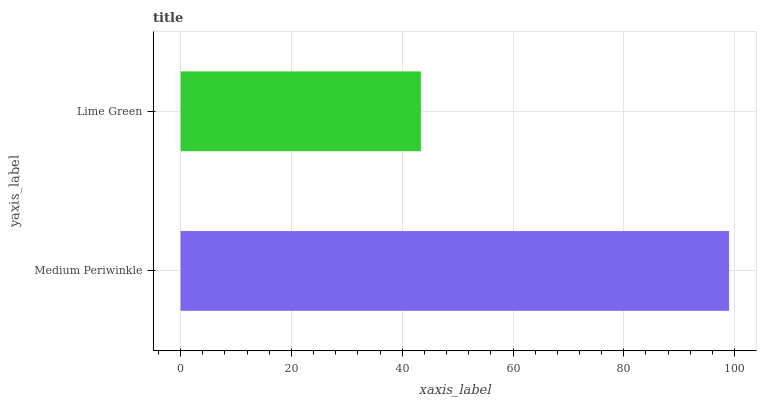Is Lime Green the minimum?
Answer yes or no. Yes. Is Medium Periwinkle the maximum?
Answer yes or no. Yes. Is Lime Green the maximum?
Answer yes or no. No. Is Medium Periwinkle greater than Lime Green?
Answer yes or no. Yes. Is Lime Green less than Medium Periwinkle?
Answer yes or no. Yes. Is Lime Green greater than Medium Periwinkle?
Answer yes or no. No. Is Medium Periwinkle less than Lime Green?
Answer yes or no. No. Is Medium Periwinkle the high median?
Answer yes or no. Yes. Is Lime Green the low median?
Answer yes or no. Yes. Is Lime Green the high median?
Answer yes or no. No. Is Medium Periwinkle the low median?
Answer yes or no. No. 